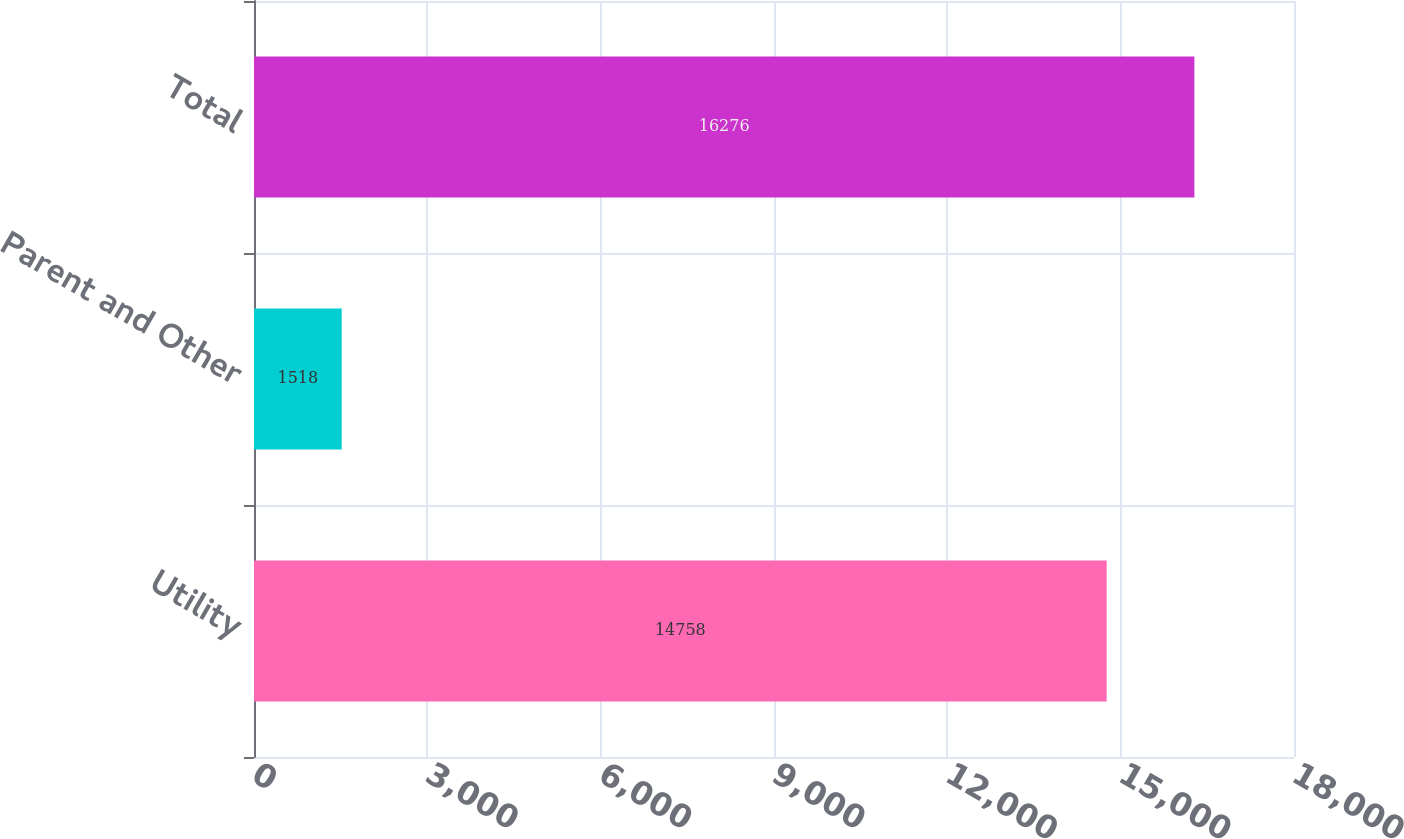Convert chart. <chart><loc_0><loc_0><loc_500><loc_500><bar_chart><fcel>Utility<fcel>Parent and Other<fcel>Total<nl><fcel>14758<fcel>1518<fcel>16276<nl></chart> 